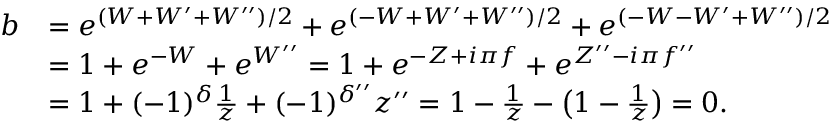<formula> <loc_0><loc_0><loc_500><loc_500>\begin{array} { r l } { b } & { = e ^ { ( W + W ^ { \prime } + W ^ { \prime \prime } ) / 2 } + e ^ { ( - W + W ^ { \prime } + W ^ { \prime \prime } ) / 2 } + e ^ { ( - W - W ^ { \prime } + W ^ { \prime \prime } ) / 2 } } \\ & { = 1 + e ^ { - W } + e ^ { W ^ { \prime \prime } } = 1 + e ^ { - Z + i \pi f } + e ^ { Z ^ { \prime \prime } - i \pi f ^ { \prime \prime } } } \\ & { = 1 + ( - 1 ) ^ { \delta } \frac { 1 } { z } + ( - 1 ) ^ { \delta ^ { \prime \prime } } z ^ { \prime \prime } = 1 - \frac { 1 } { z } - \left ( 1 - \frac { 1 } { z } \right ) = 0 . } \end{array}</formula> 